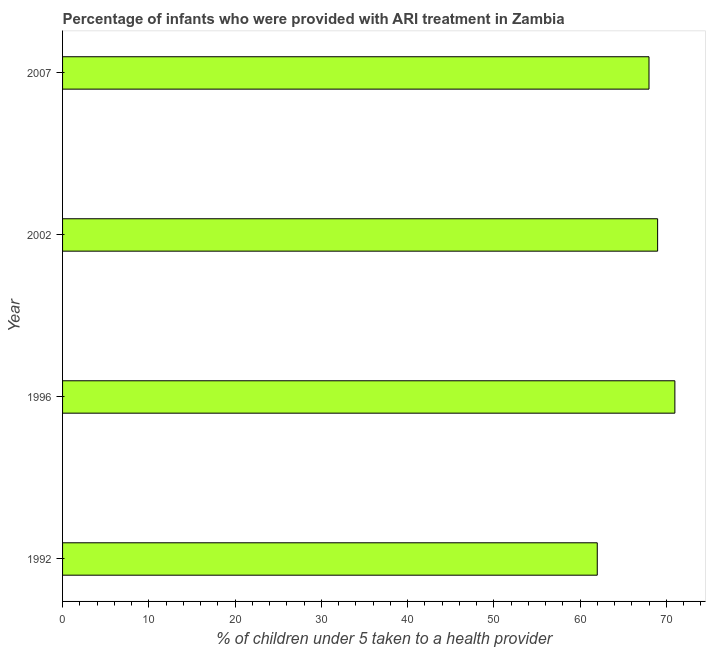Does the graph contain any zero values?
Provide a short and direct response. No. Does the graph contain grids?
Provide a short and direct response. No. What is the title of the graph?
Your answer should be compact. Percentage of infants who were provided with ARI treatment in Zambia. What is the label or title of the X-axis?
Offer a very short reply. % of children under 5 taken to a health provider. What is the percentage of children who were provided with ari treatment in 2007?
Make the answer very short. 68. In which year was the percentage of children who were provided with ari treatment maximum?
Ensure brevity in your answer.  1996. What is the sum of the percentage of children who were provided with ari treatment?
Your answer should be compact. 270. What is the difference between the percentage of children who were provided with ari treatment in 1992 and 1996?
Your answer should be compact. -9. What is the average percentage of children who were provided with ari treatment per year?
Offer a very short reply. 67. What is the median percentage of children who were provided with ari treatment?
Your response must be concise. 68.5. Do a majority of the years between 1992 and 1996 (inclusive) have percentage of children who were provided with ari treatment greater than 66 %?
Offer a terse response. No. Is the percentage of children who were provided with ari treatment in 1996 less than that in 2007?
Your answer should be compact. No. Is the sum of the percentage of children who were provided with ari treatment in 2002 and 2007 greater than the maximum percentage of children who were provided with ari treatment across all years?
Offer a terse response. Yes. In how many years, is the percentage of children who were provided with ari treatment greater than the average percentage of children who were provided with ari treatment taken over all years?
Give a very brief answer. 3. How many bars are there?
Give a very brief answer. 4. How many years are there in the graph?
Ensure brevity in your answer.  4. What is the difference between two consecutive major ticks on the X-axis?
Your response must be concise. 10. Are the values on the major ticks of X-axis written in scientific E-notation?
Offer a very short reply. No. What is the % of children under 5 taken to a health provider in 2002?
Ensure brevity in your answer.  69. What is the % of children under 5 taken to a health provider of 2007?
Your answer should be compact. 68. What is the difference between the % of children under 5 taken to a health provider in 1992 and 1996?
Your answer should be compact. -9. What is the difference between the % of children under 5 taken to a health provider in 1992 and 2007?
Provide a short and direct response. -6. What is the difference between the % of children under 5 taken to a health provider in 1996 and 2002?
Keep it short and to the point. 2. What is the difference between the % of children under 5 taken to a health provider in 2002 and 2007?
Make the answer very short. 1. What is the ratio of the % of children under 5 taken to a health provider in 1992 to that in 1996?
Ensure brevity in your answer.  0.87. What is the ratio of the % of children under 5 taken to a health provider in 1992 to that in 2002?
Offer a terse response. 0.9. What is the ratio of the % of children under 5 taken to a health provider in 1992 to that in 2007?
Your answer should be compact. 0.91. What is the ratio of the % of children under 5 taken to a health provider in 1996 to that in 2007?
Your answer should be compact. 1.04. What is the ratio of the % of children under 5 taken to a health provider in 2002 to that in 2007?
Make the answer very short. 1.01. 